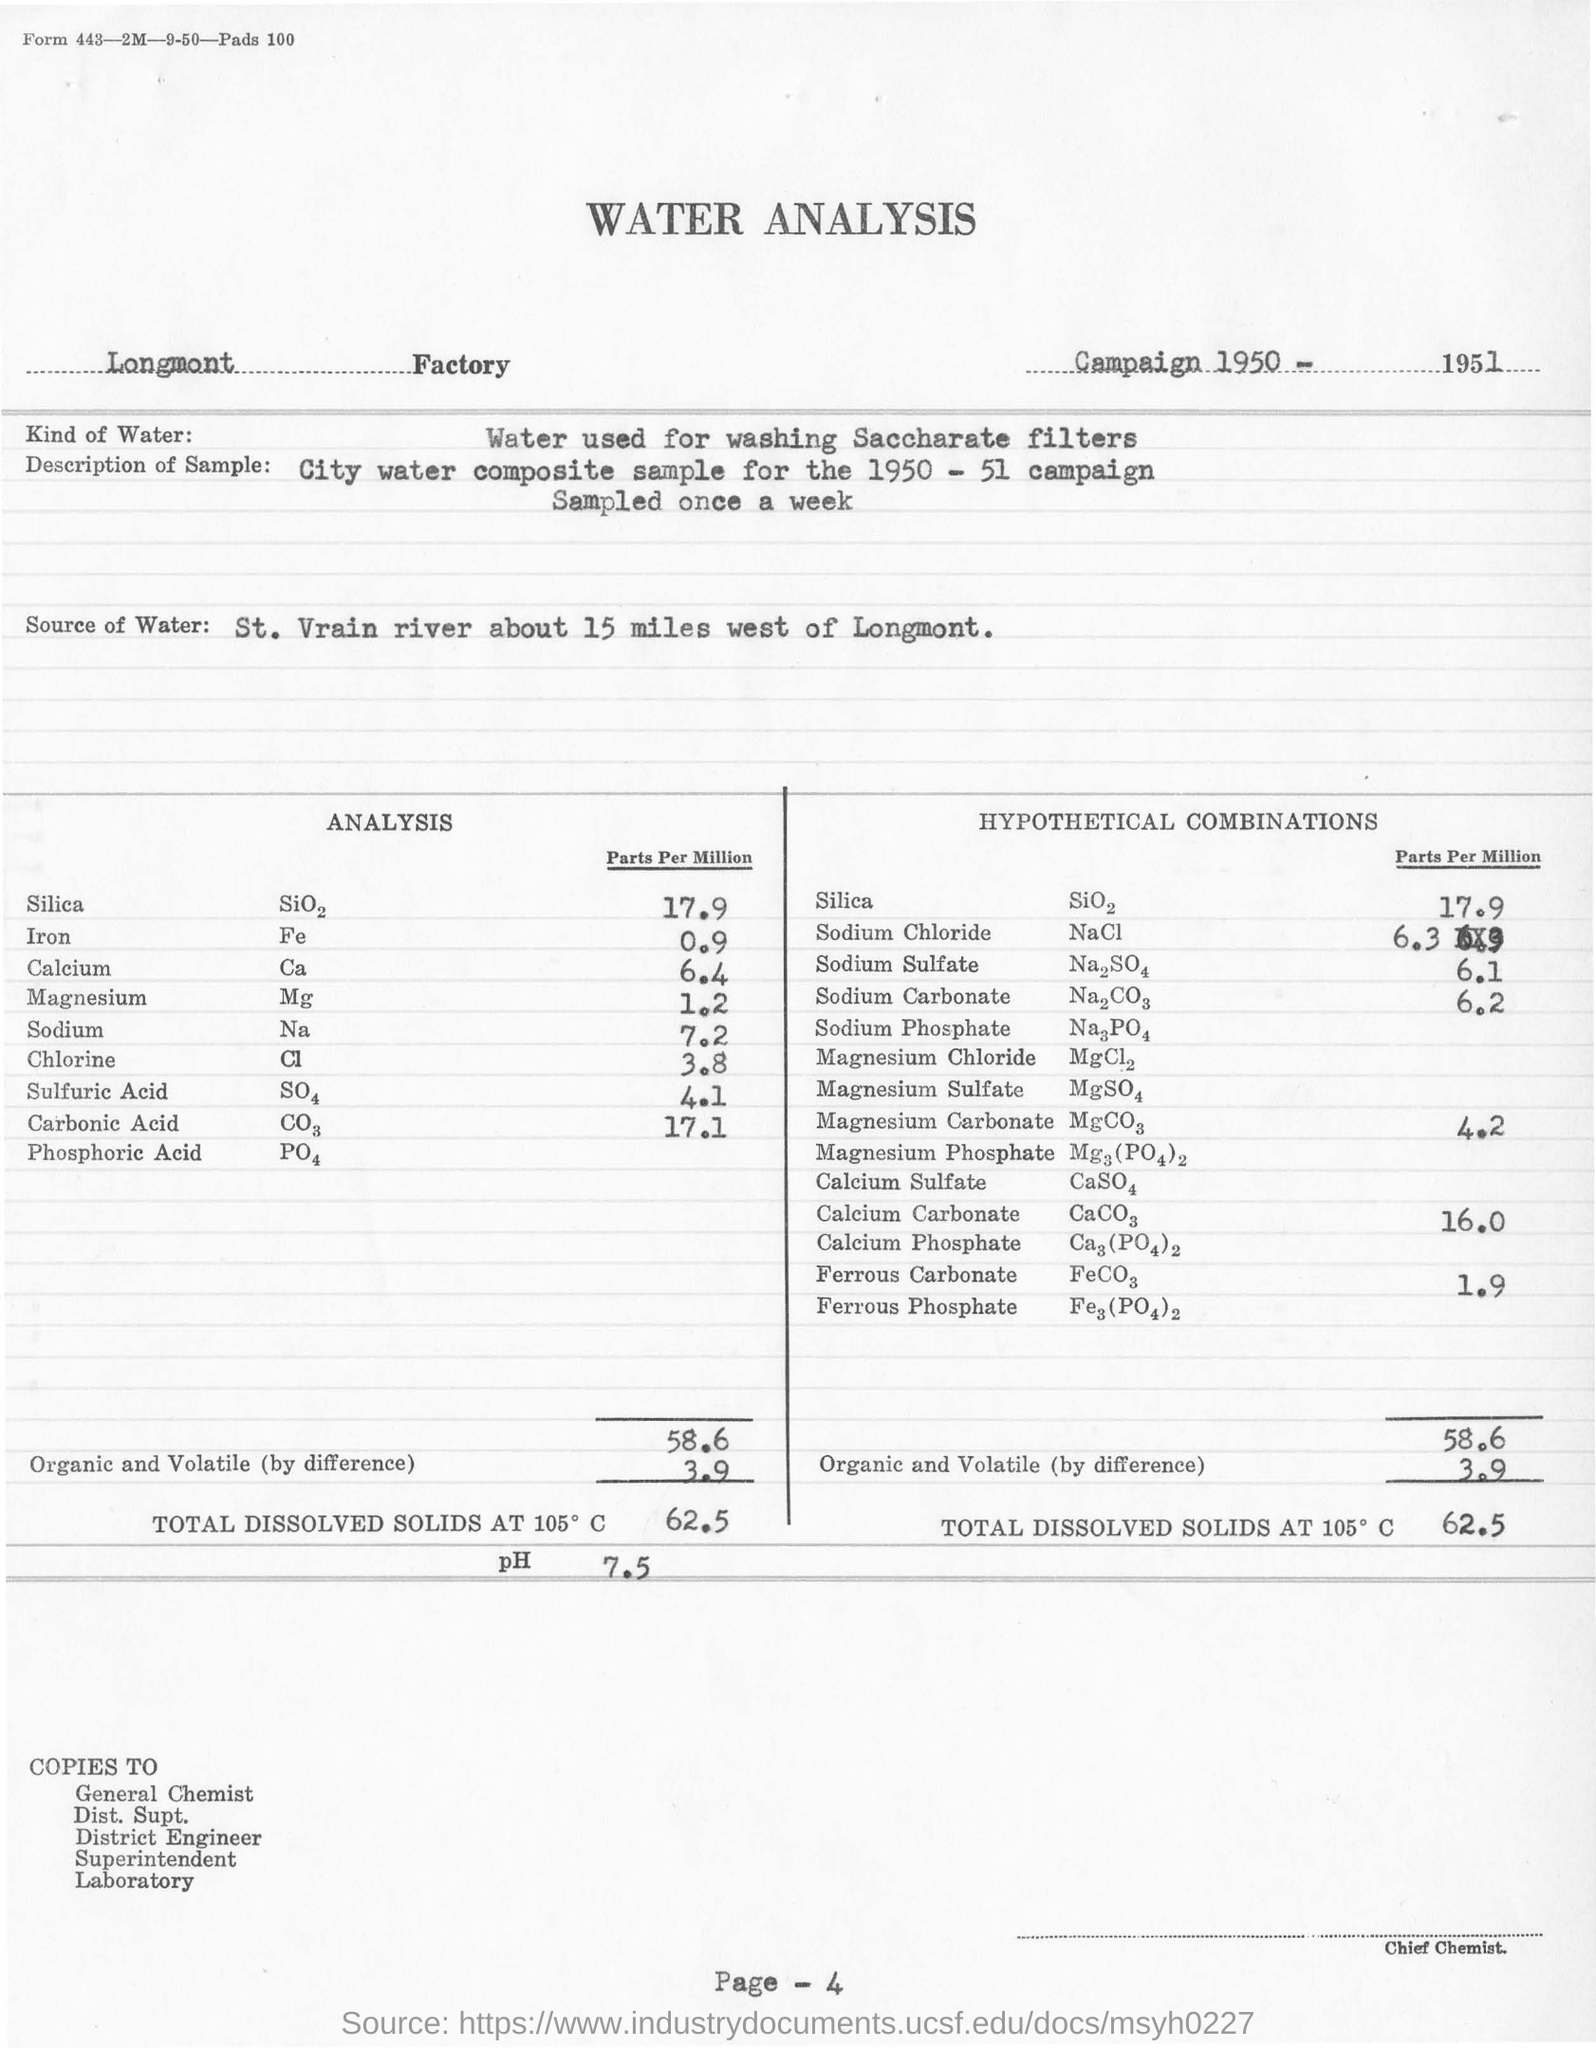In which factory is the water analysis conducted?
Your answer should be compact. Longmont   Factory. What kind of water is used for analysis?
Keep it short and to the point. Water used for washing Saccharate filters. What is the source of water for analysis?
Your response must be concise. St. Vrain river about 15 miles west of Longmont. What is the PH obtained for water Analysis?
Your answer should be compact. 7.5. What is the concentration of Silica in Parts Per Million in the analysis?
Provide a succinct answer. 17.9. What is the concentration of sodium sulfate in Parts per Million in the analysis?
Keep it short and to the point. 6.1. During which year the campaign is held?
Your answer should be compact. 1950 - 51. What is the concentration of Sodium in Parts Per Million in the analysis?
Your answer should be compact. 7.2. 